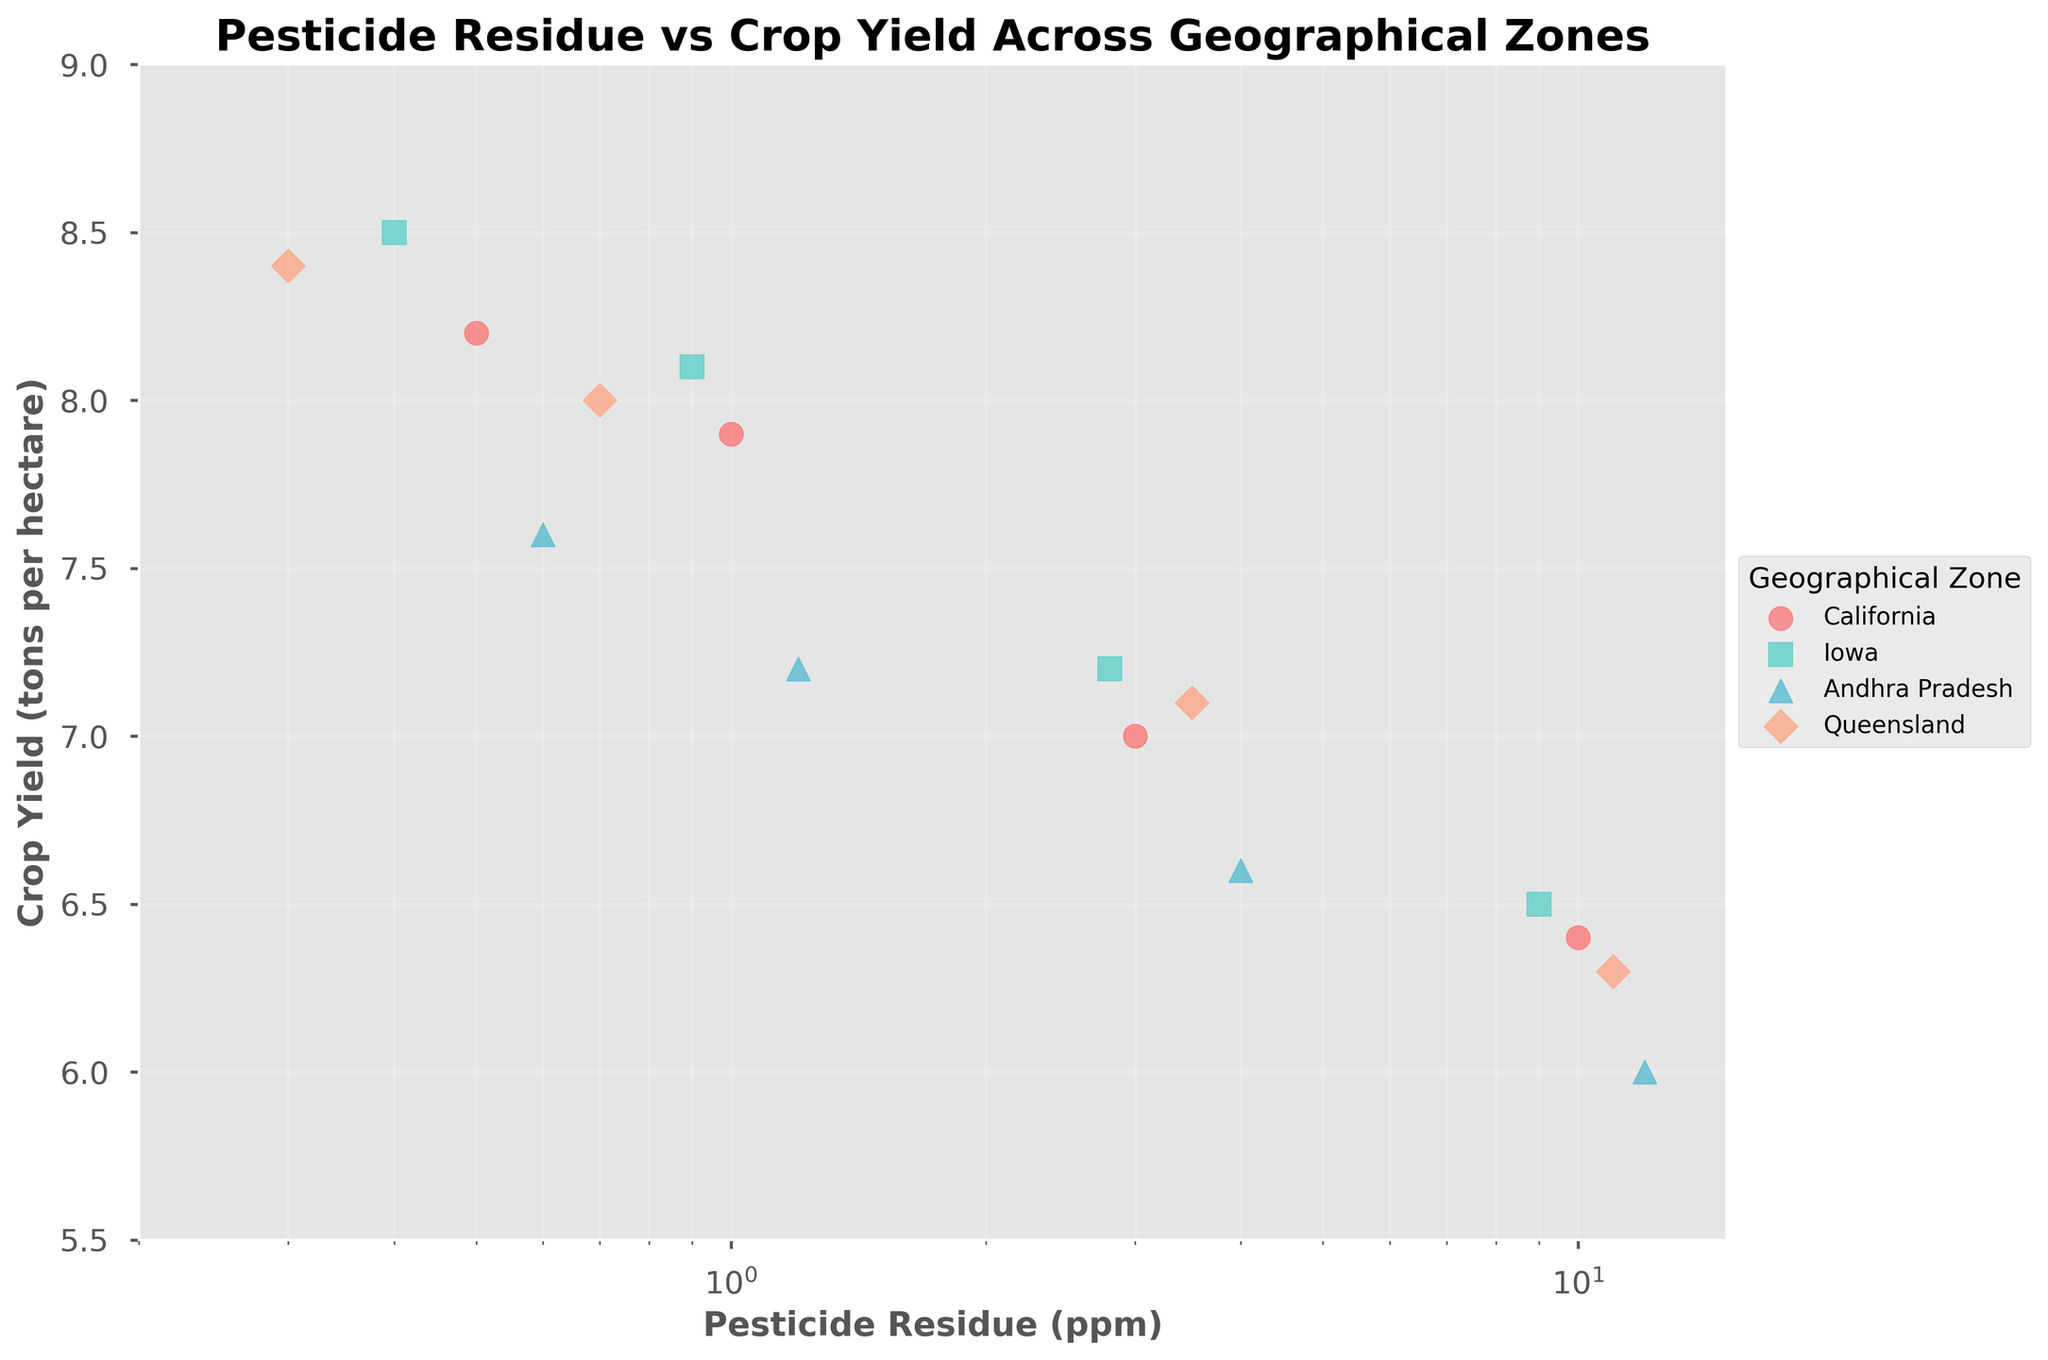What's the title of the figure? The title of the figure is displayed at the top of the chart. It provides a general overview or main topic of the data presented in the plot.
Answer: Pesticide Residue vs Crop Yield Across Geographical Zones What is the x-axis labeled as? The x-axis represents the variable being measured horizontally across the plot, and its label can be found below the axis.
Answer: Pesticide Residue (ppm) How many data points are there for Iowa? To find the number of data points for Iowa, count the individual markers associated with Iowa in the scatter plot.
Answer: 4 Which geographical zone has the highest crop yield at a pesticide residue level of 1.0 ppm? Locate the data points where the x-axis value is close to 1.0 ppm, then identify the geographical zone of the data point with the highest y-axis value.
Answer: California Compare the crop yield reduction from 0.5 ppm to 10.0 ppm pesticide residue levels for California. Find the crop yield values for California at 0.5 ppm and 10.0 ppm and calculate the difference. Subtract the lower yield (at 10.0 ppm) from the higher yield (at 0.5 ppm).
Answer: 1.8 tons per hectare Which geographical zone has the steepest decline in crop yield as pesticide residue increases? Observe the trend of the data points for each geographical zone. Identify the zone where the decrease in crop yield with increasing pesticide residue is most pronounced.
Answer: Andhra Pradesh What's the average crop yield for all data points at pesticide residue levels higher than 1 ppm? Locate all data points where the x-axis value is greater than 1 ppm, sum their corresponding y-axis (crop yield) values, and divide by the number of these data points.
Answer: 6.85 tons per hectare Which geographical zone shows the least variation in crop yield across different pesticide residue levels? Compare the spread of the crop yield values (y-axis) for each geographical zone. The zone with the smallest range or variance has the least variation.
Answer: Iowa What is the general trend of crop yield performance as pesticide residue increases in the figure? Analyze the overall pattern of the data points across all geographical zones. Summarize the common behavior of crop yield in response to increasing pesticide residue.
Answer: Decreases 